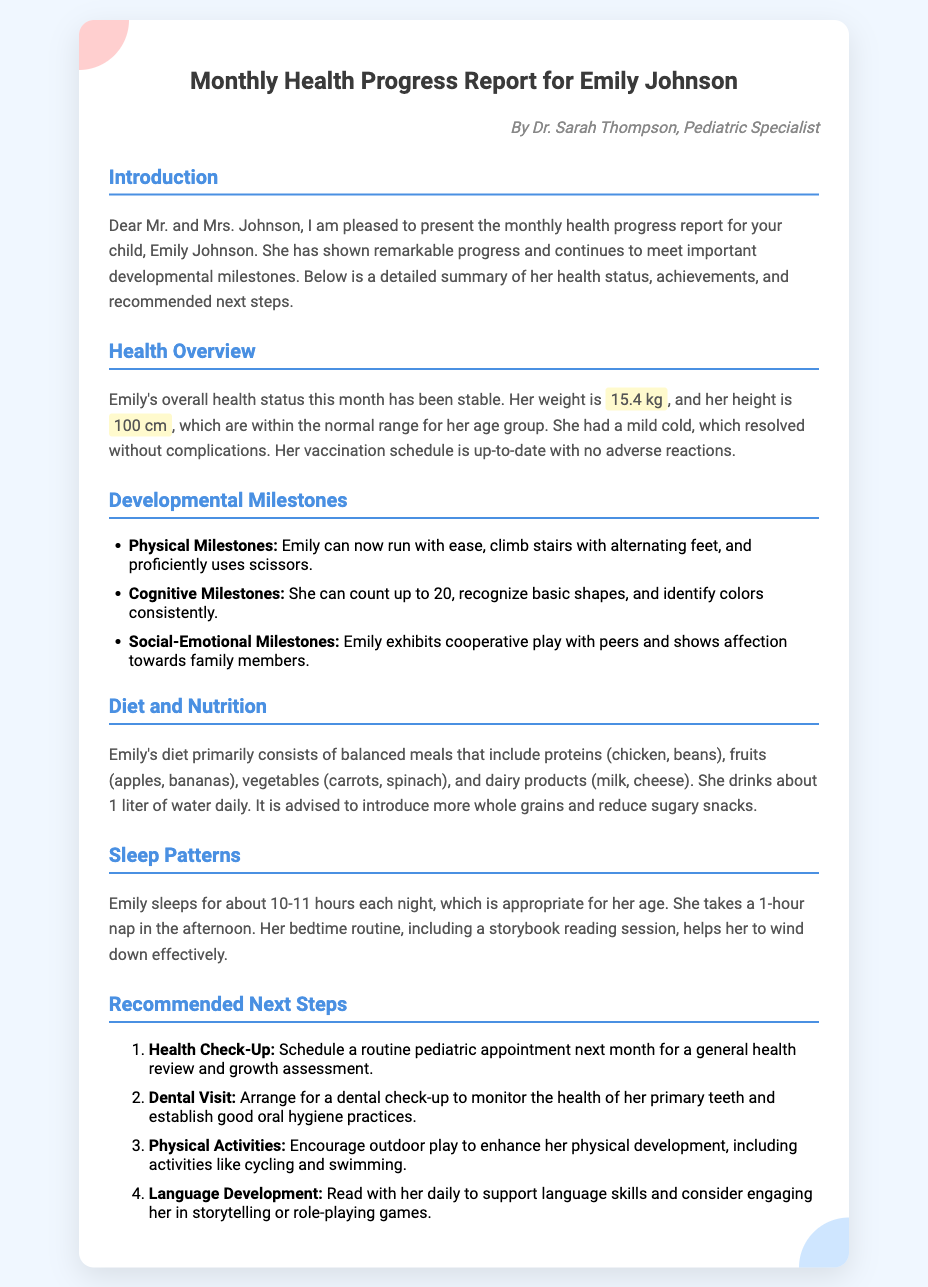What is Emily's weight? The document states Emily's weight is 15.4 kg.
Answer: 15.4 kg What is Emily's height? Emily's height is mentioned as 100 cm in the report.
Answer: 100 cm How many hours does Emily sleep each night? The report indicates Emily sleeps for about 10-11 hours each night.
Answer: 10-11 hours What are Emily's physical milestones? The document lists physical milestones as running with ease, climbing stairs with alternating feet, and using scissors proficiently.
Answer: Running, climbing stairs, scissors What is one recommended next step related to health? The report suggests scheduling a routine pediatric appointment next month for a general health review.
Answer: Health Check-Up Which fruits are included in Emily's diet? The report mentions apples and bananas as part of Emily's diet.
Answer: Apples, bananas What type of specialist wrote the report? The document specifies that the report was authored by a Pediatric Specialist.
Answer: Pediatric Specialist How much water does Emily drink daily? The report states that Emily drinks about 1 liter of water daily.
Answer: 1 liter What does Emily's sleep routine include? The document mentions that her bedtime routine includes a storybook reading session.
Answer: Storybook reading session 